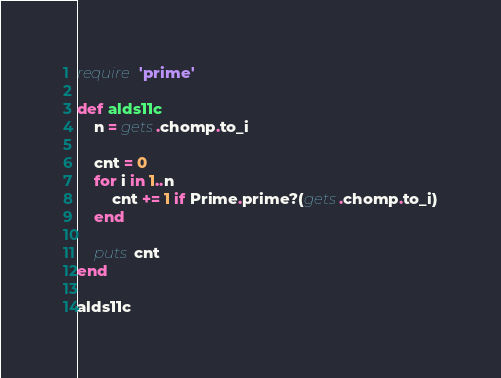<code> <loc_0><loc_0><loc_500><loc_500><_Ruby_>require 'prime'

def alds11c
    n = gets.chomp.to_i

    cnt = 0
    for i in 1..n
        cnt += 1 if Prime.prime?(gets.chomp.to_i)
    end

    puts cnt
end

alds11c

</code> 